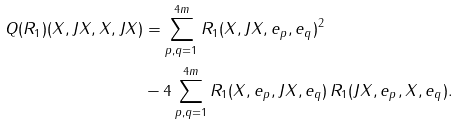<formula> <loc_0><loc_0><loc_500><loc_500>Q ( R _ { 1 } ) ( X , J X , X , J X ) & = \sum _ { p , q = 1 } ^ { 4 m } R _ { 1 } ( X , J X , e _ { p } , e _ { q } ) ^ { 2 } \\ & - 4 \sum _ { p , q = 1 } ^ { 4 m } R _ { 1 } ( X , e _ { p } , J X , e _ { q } ) \, R _ { 1 } ( J X , e _ { p } , X , e _ { q } ) .</formula> 